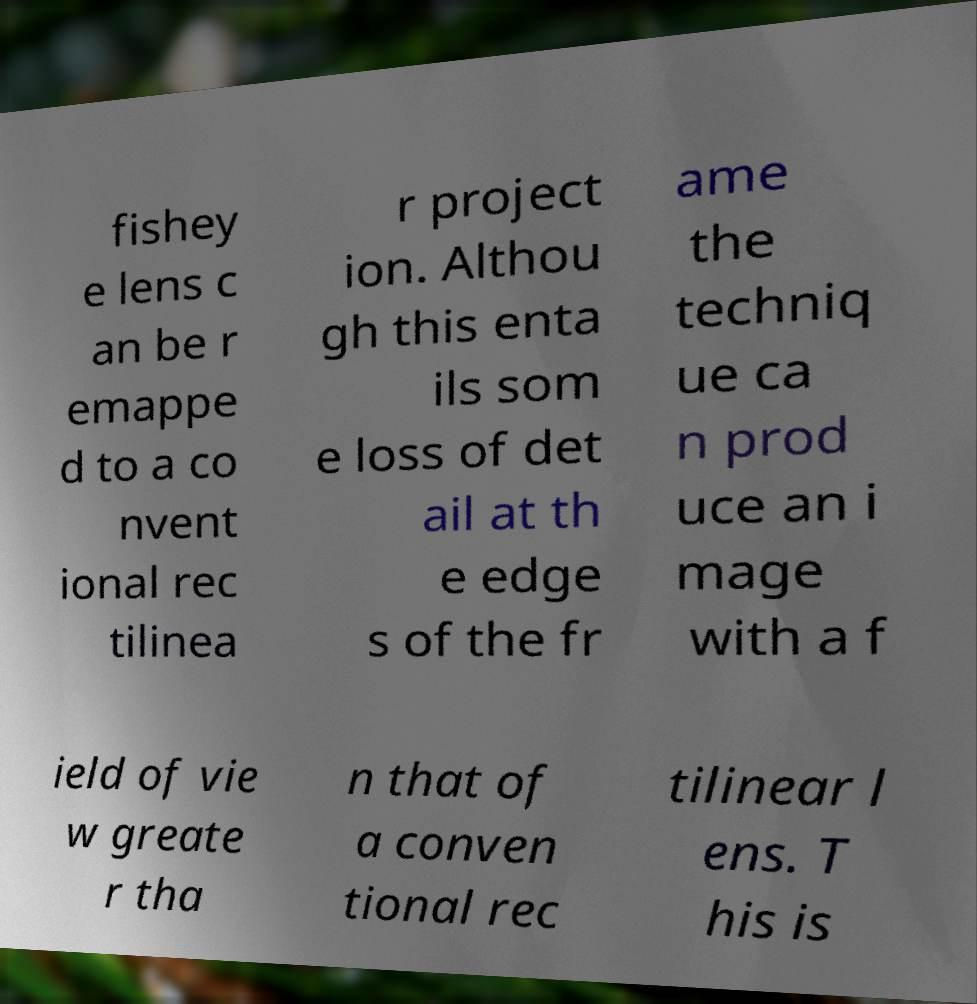Can you read and provide the text displayed in the image?This photo seems to have some interesting text. Can you extract and type it out for me? fishey e lens c an be r emappe d to a co nvent ional rec tilinea r project ion. Althou gh this enta ils som e loss of det ail at th e edge s of the fr ame the techniq ue ca n prod uce an i mage with a f ield of vie w greate r tha n that of a conven tional rec tilinear l ens. T his is 